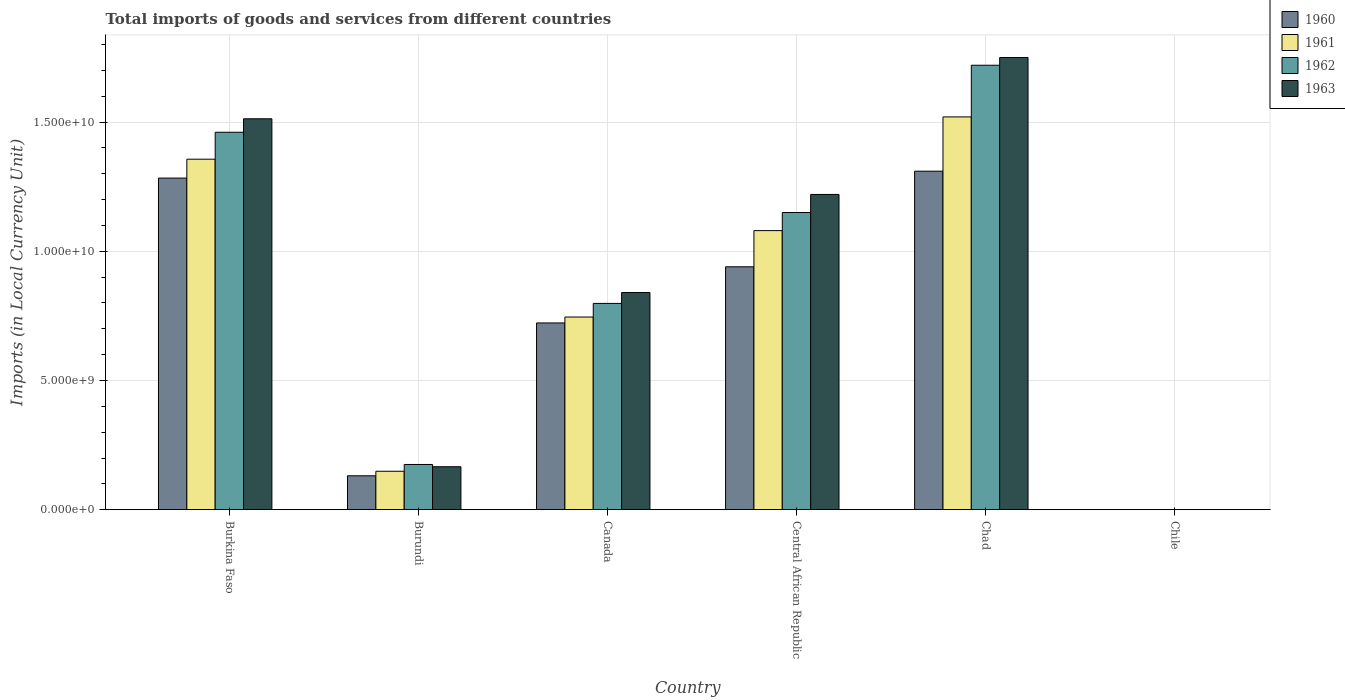How many different coloured bars are there?
Make the answer very short. 4. How many groups of bars are there?
Provide a succinct answer. 6. Are the number of bars per tick equal to the number of legend labels?
Your answer should be very brief. Yes. Are the number of bars on each tick of the X-axis equal?
Offer a terse response. Yes. How many bars are there on the 3rd tick from the left?
Your answer should be compact. 4. What is the label of the 1st group of bars from the left?
Your answer should be very brief. Burkina Faso. In how many cases, is the number of bars for a given country not equal to the number of legend labels?
Offer a terse response. 0. What is the Amount of goods and services imports in 1961 in Chad?
Your answer should be very brief. 1.52e+1. Across all countries, what is the maximum Amount of goods and services imports in 1961?
Give a very brief answer. 1.52e+1. Across all countries, what is the minimum Amount of goods and services imports in 1961?
Provide a succinct answer. 8.00e+05. In which country was the Amount of goods and services imports in 1963 maximum?
Your answer should be very brief. Chad. What is the total Amount of goods and services imports in 1961 in the graph?
Your answer should be compact. 4.85e+1. What is the difference between the Amount of goods and services imports in 1961 in Central African Republic and that in Chad?
Keep it short and to the point. -4.40e+09. What is the difference between the Amount of goods and services imports in 1963 in Chile and the Amount of goods and services imports in 1962 in Burundi?
Your answer should be very brief. -1.75e+09. What is the average Amount of goods and services imports in 1961 per country?
Provide a succinct answer. 8.08e+09. What is the difference between the Amount of goods and services imports of/in 1961 and Amount of goods and services imports of/in 1962 in Burundi?
Your response must be concise. -2.62e+08. What is the ratio of the Amount of goods and services imports in 1961 in Canada to that in Chile?
Give a very brief answer. 9319.38. What is the difference between the highest and the second highest Amount of goods and services imports in 1962?
Make the answer very short. 2.59e+09. What is the difference between the highest and the lowest Amount of goods and services imports in 1962?
Keep it short and to the point. 1.72e+1. In how many countries, is the Amount of goods and services imports in 1962 greater than the average Amount of goods and services imports in 1962 taken over all countries?
Your answer should be compact. 3. What does the 2nd bar from the left in Burkina Faso represents?
Provide a short and direct response. 1961. Is it the case that in every country, the sum of the Amount of goods and services imports in 1960 and Amount of goods and services imports in 1962 is greater than the Amount of goods and services imports in 1961?
Keep it short and to the point. Yes. How many bars are there?
Provide a succinct answer. 24. Are all the bars in the graph horizontal?
Make the answer very short. No. How many countries are there in the graph?
Offer a very short reply. 6. What is the difference between two consecutive major ticks on the Y-axis?
Your answer should be compact. 5.00e+09. Where does the legend appear in the graph?
Your response must be concise. Top right. How many legend labels are there?
Keep it short and to the point. 4. What is the title of the graph?
Make the answer very short. Total imports of goods and services from different countries. Does "1963" appear as one of the legend labels in the graph?
Your response must be concise. Yes. What is the label or title of the Y-axis?
Give a very brief answer. Imports (in Local Currency Unit). What is the Imports (in Local Currency Unit) in 1960 in Burkina Faso?
Keep it short and to the point. 1.28e+1. What is the Imports (in Local Currency Unit) in 1961 in Burkina Faso?
Provide a short and direct response. 1.36e+1. What is the Imports (in Local Currency Unit) in 1962 in Burkina Faso?
Give a very brief answer. 1.46e+1. What is the Imports (in Local Currency Unit) of 1963 in Burkina Faso?
Ensure brevity in your answer.  1.51e+1. What is the Imports (in Local Currency Unit) of 1960 in Burundi?
Offer a very short reply. 1.31e+09. What is the Imports (in Local Currency Unit) in 1961 in Burundi?
Provide a short and direct response. 1.49e+09. What is the Imports (in Local Currency Unit) in 1962 in Burundi?
Your response must be concise. 1.75e+09. What is the Imports (in Local Currency Unit) of 1963 in Burundi?
Your response must be concise. 1.66e+09. What is the Imports (in Local Currency Unit) of 1960 in Canada?
Provide a short and direct response. 7.23e+09. What is the Imports (in Local Currency Unit) in 1961 in Canada?
Make the answer very short. 7.46e+09. What is the Imports (in Local Currency Unit) in 1962 in Canada?
Make the answer very short. 7.98e+09. What is the Imports (in Local Currency Unit) of 1963 in Canada?
Your answer should be very brief. 8.40e+09. What is the Imports (in Local Currency Unit) of 1960 in Central African Republic?
Provide a short and direct response. 9.40e+09. What is the Imports (in Local Currency Unit) in 1961 in Central African Republic?
Your response must be concise. 1.08e+1. What is the Imports (in Local Currency Unit) of 1962 in Central African Republic?
Ensure brevity in your answer.  1.15e+1. What is the Imports (in Local Currency Unit) of 1963 in Central African Republic?
Give a very brief answer. 1.22e+1. What is the Imports (in Local Currency Unit) of 1960 in Chad?
Provide a succinct answer. 1.31e+1. What is the Imports (in Local Currency Unit) in 1961 in Chad?
Make the answer very short. 1.52e+1. What is the Imports (in Local Currency Unit) in 1962 in Chad?
Ensure brevity in your answer.  1.72e+1. What is the Imports (in Local Currency Unit) of 1963 in Chad?
Keep it short and to the point. 1.75e+1. What is the Imports (in Local Currency Unit) in 1960 in Chile?
Provide a succinct answer. 7.00e+05. What is the Imports (in Local Currency Unit) in 1961 in Chile?
Ensure brevity in your answer.  8.00e+05. What is the Imports (in Local Currency Unit) in 1963 in Chile?
Your response must be concise. 1.30e+06. Across all countries, what is the maximum Imports (in Local Currency Unit) of 1960?
Your answer should be very brief. 1.31e+1. Across all countries, what is the maximum Imports (in Local Currency Unit) in 1961?
Give a very brief answer. 1.52e+1. Across all countries, what is the maximum Imports (in Local Currency Unit) in 1962?
Offer a terse response. 1.72e+1. Across all countries, what is the maximum Imports (in Local Currency Unit) in 1963?
Offer a terse response. 1.75e+1. Across all countries, what is the minimum Imports (in Local Currency Unit) of 1963?
Provide a short and direct response. 1.30e+06. What is the total Imports (in Local Currency Unit) of 1960 in the graph?
Provide a short and direct response. 4.39e+1. What is the total Imports (in Local Currency Unit) of 1961 in the graph?
Make the answer very short. 4.85e+1. What is the total Imports (in Local Currency Unit) in 1962 in the graph?
Ensure brevity in your answer.  5.30e+1. What is the total Imports (in Local Currency Unit) in 1963 in the graph?
Make the answer very short. 5.49e+1. What is the difference between the Imports (in Local Currency Unit) in 1960 in Burkina Faso and that in Burundi?
Give a very brief answer. 1.15e+1. What is the difference between the Imports (in Local Currency Unit) of 1961 in Burkina Faso and that in Burundi?
Offer a terse response. 1.21e+1. What is the difference between the Imports (in Local Currency Unit) of 1962 in Burkina Faso and that in Burundi?
Ensure brevity in your answer.  1.29e+1. What is the difference between the Imports (in Local Currency Unit) of 1963 in Burkina Faso and that in Burundi?
Keep it short and to the point. 1.35e+1. What is the difference between the Imports (in Local Currency Unit) in 1960 in Burkina Faso and that in Canada?
Give a very brief answer. 5.61e+09. What is the difference between the Imports (in Local Currency Unit) of 1961 in Burkina Faso and that in Canada?
Offer a terse response. 6.11e+09. What is the difference between the Imports (in Local Currency Unit) of 1962 in Burkina Faso and that in Canada?
Provide a short and direct response. 6.62e+09. What is the difference between the Imports (in Local Currency Unit) of 1963 in Burkina Faso and that in Canada?
Make the answer very short. 6.72e+09. What is the difference between the Imports (in Local Currency Unit) in 1960 in Burkina Faso and that in Central African Republic?
Your answer should be compact. 3.43e+09. What is the difference between the Imports (in Local Currency Unit) of 1961 in Burkina Faso and that in Central African Republic?
Make the answer very short. 2.76e+09. What is the difference between the Imports (in Local Currency Unit) in 1962 in Burkina Faso and that in Central African Republic?
Ensure brevity in your answer.  3.11e+09. What is the difference between the Imports (in Local Currency Unit) of 1963 in Burkina Faso and that in Central African Republic?
Make the answer very short. 2.93e+09. What is the difference between the Imports (in Local Currency Unit) in 1960 in Burkina Faso and that in Chad?
Give a very brief answer. -2.66e+08. What is the difference between the Imports (in Local Currency Unit) of 1961 in Burkina Faso and that in Chad?
Give a very brief answer. -1.64e+09. What is the difference between the Imports (in Local Currency Unit) of 1962 in Burkina Faso and that in Chad?
Offer a terse response. -2.59e+09. What is the difference between the Imports (in Local Currency Unit) of 1963 in Burkina Faso and that in Chad?
Your response must be concise. -2.37e+09. What is the difference between the Imports (in Local Currency Unit) of 1960 in Burkina Faso and that in Chile?
Your response must be concise. 1.28e+1. What is the difference between the Imports (in Local Currency Unit) in 1961 in Burkina Faso and that in Chile?
Your answer should be very brief. 1.36e+1. What is the difference between the Imports (in Local Currency Unit) in 1962 in Burkina Faso and that in Chile?
Your response must be concise. 1.46e+1. What is the difference between the Imports (in Local Currency Unit) in 1963 in Burkina Faso and that in Chile?
Your answer should be compact. 1.51e+1. What is the difference between the Imports (in Local Currency Unit) in 1960 in Burundi and that in Canada?
Offer a very short reply. -5.91e+09. What is the difference between the Imports (in Local Currency Unit) in 1961 in Burundi and that in Canada?
Your answer should be compact. -5.97e+09. What is the difference between the Imports (in Local Currency Unit) of 1962 in Burundi and that in Canada?
Your answer should be compact. -6.23e+09. What is the difference between the Imports (in Local Currency Unit) of 1963 in Burundi and that in Canada?
Offer a terse response. -6.74e+09. What is the difference between the Imports (in Local Currency Unit) of 1960 in Burundi and that in Central African Republic?
Give a very brief answer. -8.09e+09. What is the difference between the Imports (in Local Currency Unit) of 1961 in Burundi and that in Central African Republic?
Offer a terse response. -9.31e+09. What is the difference between the Imports (in Local Currency Unit) in 1962 in Burundi and that in Central African Republic?
Provide a succinct answer. -9.75e+09. What is the difference between the Imports (in Local Currency Unit) in 1963 in Burundi and that in Central African Republic?
Provide a succinct answer. -1.05e+1. What is the difference between the Imports (in Local Currency Unit) of 1960 in Burundi and that in Chad?
Provide a short and direct response. -1.18e+1. What is the difference between the Imports (in Local Currency Unit) in 1961 in Burundi and that in Chad?
Offer a very short reply. -1.37e+1. What is the difference between the Imports (in Local Currency Unit) in 1962 in Burundi and that in Chad?
Your response must be concise. -1.55e+1. What is the difference between the Imports (in Local Currency Unit) in 1963 in Burundi and that in Chad?
Provide a short and direct response. -1.58e+1. What is the difference between the Imports (in Local Currency Unit) in 1960 in Burundi and that in Chile?
Keep it short and to the point. 1.31e+09. What is the difference between the Imports (in Local Currency Unit) in 1961 in Burundi and that in Chile?
Offer a terse response. 1.49e+09. What is the difference between the Imports (in Local Currency Unit) of 1962 in Burundi and that in Chile?
Your answer should be very brief. 1.75e+09. What is the difference between the Imports (in Local Currency Unit) in 1963 in Burundi and that in Chile?
Offer a very short reply. 1.66e+09. What is the difference between the Imports (in Local Currency Unit) in 1960 in Canada and that in Central African Republic?
Keep it short and to the point. -2.17e+09. What is the difference between the Imports (in Local Currency Unit) of 1961 in Canada and that in Central African Republic?
Your answer should be very brief. -3.34e+09. What is the difference between the Imports (in Local Currency Unit) of 1962 in Canada and that in Central African Republic?
Keep it short and to the point. -3.52e+09. What is the difference between the Imports (in Local Currency Unit) of 1963 in Canada and that in Central African Republic?
Make the answer very short. -3.80e+09. What is the difference between the Imports (in Local Currency Unit) in 1960 in Canada and that in Chad?
Offer a terse response. -5.87e+09. What is the difference between the Imports (in Local Currency Unit) in 1961 in Canada and that in Chad?
Provide a succinct answer. -7.74e+09. What is the difference between the Imports (in Local Currency Unit) in 1962 in Canada and that in Chad?
Keep it short and to the point. -9.22e+09. What is the difference between the Imports (in Local Currency Unit) of 1963 in Canada and that in Chad?
Your answer should be compact. -9.10e+09. What is the difference between the Imports (in Local Currency Unit) of 1960 in Canada and that in Chile?
Keep it short and to the point. 7.23e+09. What is the difference between the Imports (in Local Currency Unit) in 1961 in Canada and that in Chile?
Provide a succinct answer. 7.45e+09. What is the difference between the Imports (in Local Currency Unit) of 1962 in Canada and that in Chile?
Keep it short and to the point. 7.98e+09. What is the difference between the Imports (in Local Currency Unit) of 1963 in Canada and that in Chile?
Your answer should be very brief. 8.40e+09. What is the difference between the Imports (in Local Currency Unit) of 1960 in Central African Republic and that in Chad?
Offer a terse response. -3.70e+09. What is the difference between the Imports (in Local Currency Unit) in 1961 in Central African Republic and that in Chad?
Your answer should be very brief. -4.40e+09. What is the difference between the Imports (in Local Currency Unit) in 1962 in Central African Republic and that in Chad?
Your answer should be compact. -5.70e+09. What is the difference between the Imports (in Local Currency Unit) of 1963 in Central African Republic and that in Chad?
Give a very brief answer. -5.30e+09. What is the difference between the Imports (in Local Currency Unit) of 1960 in Central African Republic and that in Chile?
Keep it short and to the point. 9.40e+09. What is the difference between the Imports (in Local Currency Unit) in 1961 in Central African Republic and that in Chile?
Give a very brief answer. 1.08e+1. What is the difference between the Imports (in Local Currency Unit) in 1962 in Central African Republic and that in Chile?
Provide a succinct answer. 1.15e+1. What is the difference between the Imports (in Local Currency Unit) of 1963 in Central African Republic and that in Chile?
Make the answer very short. 1.22e+1. What is the difference between the Imports (in Local Currency Unit) of 1960 in Chad and that in Chile?
Provide a succinct answer. 1.31e+1. What is the difference between the Imports (in Local Currency Unit) in 1961 in Chad and that in Chile?
Give a very brief answer. 1.52e+1. What is the difference between the Imports (in Local Currency Unit) in 1962 in Chad and that in Chile?
Keep it short and to the point. 1.72e+1. What is the difference between the Imports (in Local Currency Unit) in 1963 in Chad and that in Chile?
Give a very brief answer. 1.75e+1. What is the difference between the Imports (in Local Currency Unit) of 1960 in Burkina Faso and the Imports (in Local Currency Unit) of 1961 in Burundi?
Give a very brief answer. 1.13e+1. What is the difference between the Imports (in Local Currency Unit) of 1960 in Burkina Faso and the Imports (in Local Currency Unit) of 1962 in Burundi?
Give a very brief answer. 1.11e+1. What is the difference between the Imports (in Local Currency Unit) in 1960 in Burkina Faso and the Imports (in Local Currency Unit) in 1963 in Burundi?
Your response must be concise. 1.12e+1. What is the difference between the Imports (in Local Currency Unit) in 1961 in Burkina Faso and the Imports (in Local Currency Unit) in 1962 in Burundi?
Ensure brevity in your answer.  1.18e+1. What is the difference between the Imports (in Local Currency Unit) of 1961 in Burkina Faso and the Imports (in Local Currency Unit) of 1963 in Burundi?
Provide a short and direct response. 1.19e+1. What is the difference between the Imports (in Local Currency Unit) of 1962 in Burkina Faso and the Imports (in Local Currency Unit) of 1963 in Burundi?
Offer a terse response. 1.29e+1. What is the difference between the Imports (in Local Currency Unit) in 1960 in Burkina Faso and the Imports (in Local Currency Unit) in 1961 in Canada?
Provide a succinct answer. 5.38e+09. What is the difference between the Imports (in Local Currency Unit) in 1960 in Burkina Faso and the Imports (in Local Currency Unit) in 1962 in Canada?
Provide a succinct answer. 4.85e+09. What is the difference between the Imports (in Local Currency Unit) in 1960 in Burkina Faso and the Imports (in Local Currency Unit) in 1963 in Canada?
Your answer should be compact. 4.43e+09. What is the difference between the Imports (in Local Currency Unit) in 1961 in Burkina Faso and the Imports (in Local Currency Unit) in 1962 in Canada?
Provide a succinct answer. 5.58e+09. What is the difference between the Imports (in Local Currency Unit) in 1961 in Burkina Faso and the Imports (in Local Currency Unit) in 1963 in Canada?
Give a very brief answer. 5.16e+09. What is the difference between the Imports (in Local Currency Unit) of 1962 in Burkina Faso and the Imports (in Local Currency Unit) of 1963 in Canada?
Your answer should be compact. 6.20e+09. What is the difference between the Imports (in Local Currency Unit) of 1960 in Burkina Faso and the Imports (in Local Currency Unit) of 1961 in Central African Republic?
Make the answer very short. 2.03e+09. What is the difference between the Imports (in Local Currency Unit) in 1960 in Burkina Faso and the Imports (in Local Currency Unit) in 1962 in Central African Republic?
Make the answer very short. 1.33e+09. What is the difference between the Imports (in Local Currency Unit) in 1960 in Burkina Faso and the Imports (in Local Currency Unit) in 1963 in Central African Republic?
Your answer should be very brief. 6.34e+08. What is the difference between the Imports (in Local Currency Unit) in 1961 in Burkina Faso and the Imports (in Local Currency Unit) in 1962 in Central African Republic?
Offer a very short reply. 2.06e+09. What is the difference between the Imports (in Local Currency Unit) in 1961 in Burkina Faso and the Imports (in Local Currency Unit) in 1963 in Central African Republic?
Your response must be concise. 1.36e+09. What is the difference between the Imports (in Local Currency Unit) of 1962 in Burkina Faso and the Imports (in Local Currency Unit) of 1963 in Central African Republic?
Your response must be concise. 2.41e+09. What is the difference between the Imports (in Local Currency Unit) of 1960 in Burkina Faso and the Imports (in Local Currency Unit) of 1961 in Chad?
Provide a short and direct response. -2.37e+09. What is the difference between the Imports (in Local Currency Unit) in 1960 in Burkina Faso and the Imports (in Local Currency Unit) in 1962 in Chad?
Offer a very short reply. -4.37e+09. What is the difference between the Imports (in Local Currency Unit) in 1960 in Burkina Faso and the Imports (in Local Currency Unit) in 1963 in Chad?
Make the answer very short. -4.67e+09. What is the difference between the Imports (in Local Currency Unit) of 1961 in Burkina Faso and the Imports (in Local Currency Unit) of 1962 in Chad?
Give a very brief answer. -3.64e+09. What is the difference between the Imports (in Local Currency Unit) of 1961 in Burkina Faso and the Imports (in Local Currency Unit) of 1963 in Chad?
Your response must be concise. -3.94e+09. What is the difference between the Imports (in Local Currency Unit) in 1962 in Burkina Faso and the Imports (in Local Currency Unit) in 1963 in Chad?
Your answer should be very brief. -2.89e+09. What is the difference between the Imports (in Local Currency Unit) of 1960 in Burkina Faso and the Imports (in Local Currency Unit) of 1961 in Chile?
Keep it short and to the point. 1.28e+1. What is the difference between the Imports (in Local Currency Unit) of 1960 in Burkina Faso and the Imports (in Local Currency Unit) of 1962 in Chile?
Make the answer very short. 1.28e+1. What is the difference between the Imports (in Local Currency Unit) in 1960 in Burkina Faso and the Imports (in Local Currency Unit) in 1963 in Chile?
Provide a succinct answer. 1.28e+1. What is the difference between the Imports (in Local Currency Unit) of 1961 in Burkina Faso and the Imports (in Local Currency Unit) of 1962 in Chile?
Your answer should be very brief. 1.36e+1. What is the difference between the Imports (in Local Currency Unit) in 1961 in Burkina Faso and the Imports (in Local Currency Unit) in 1963 in Chile?
Provide a succinct answer. 1.36e+1. What is the difference between the Imports (in Local Currency Unit) in 1962 in Burkina Faso and the Imports (in Local Currency Unit) in 1963 in Chile?
Provide a short and direct response. 1.46e+1. What is the difference between the Imports (in Local Currency Unit) of 1960 in Burundi and the Imports (in Local Currency Unit) of 1961 in Canada?
Ensure brevity in your answer.  -6.14e+09. What is the difference between the Imports (in Local Currency Unit) of 1960 in Burundi and the Imports (in Local Currency Unit) of 1962 in Canada?
Ensure brevity in your answer.  -6.67e+09. What is the difference between the Imports (in Local Currency Unit) in 1960 in Burundi and the Imports (in Local Currency Unit) in 1963 in Canada?
Offer a terse response. -7.09e+09. What is the difference between the Imports (in Local Currency Unit) of 1961 in Burundi and the Imports (in Local Currency Unit) of 1962 in Canada?
Your response must be concise. -6.50e+09. What is the difference between the Imports (in Local Currency Unit) of 1961 in Burundi and the Imports (in Local Currency Unit) of 1963 in Canada?
Offer a very short reply. -6.92e+09. What is the difference between the Imports (in Local Currency Unit) of 1962 in Burundi and the Imports (in Local Currency Unit) of 1963 in Canada?
Give a very brief answer. -6.65e+09. What is the difference between the Imports (in Local Currency Unit) in 1960 in Burundi and the Imports (in Local Currency Unit) in 1961 in Central African Republic?
Your answer should be compact. -9.49e+09. What is the difference between the Imports (in Local Currency Unit) of 1960 in Burundi and the Imports (in Local Currency Unit) of 1962 in Central African Republic?
Your answer should be very brief. -1.02e+1. What is the difference between the Imports (in Local Currency Unit) of 1960 in Burundi and the Imports (in Local Currency Unit) of 1963 in Central African Republic?
Ensure brevity in your answer.  -1.09e+1. What is the difference between the Imports (in Local Currency Unit) in 1961 in Burundi and the Imports (in Local Currency Unit) in 1962 in Central African Republic?
Ensure brevity in your answer.  -1.00e+1. What is the difference between the Imports (in Local Currency Unit) of 1961 in Burundi and the Imports (in Local Currency Unit) of 1963 in Central African Republic?
Give a very brief answer. -1.07e+1. What is the difference between the Imports (in Local Currency Unit) of 1962 in Burundi and the Imports (in Local Currency Unit) of 1963 in Central African Republic?
Your answer should be very brief. -1.05e+1. What is the difference between the Imports (in Local Currency Unit) in 1960 in Burundi and the Imports (in Local Currency Unit) in 1961 in Chad?
Offer a very short reply. -1.39e+1. What is the difference between the Imports (in Local Currency Unit) of 1960 in Burundi and the Imports (in Local Currency Unit) of 1962 in Chad?
Your response must be concise. -1.59e+1. What is the difference between the Imports (in Local Currency Unit) in 1960 in Burundi and the Imports (in Local Currency Unit) in 1963 in Chad?
Provide a succinct answer. -1.62e+1. What is the difference between the Imports (in Local Currency Unit) of 1961 in Burundi and the Imports (in Local Currency Unit) of 1962 in Chad?
Your answer should be very brief. -1.57e+1. What is the difference between the Imports (in Local Currency Unit) of 1961 in Burundi and the Imports (in Local Currency Unit) of 1963 in Chad?
Make the answer very short. -1.60e+1. What is the difference between the Imports (in Local Currency Unit) of 1962 in Burundi and the Imports (in Local Currency Unit) of 1963 in Chad?
Your answer should be very brief. -1.58e+1. What is the difference between the Imports (in Local Currency Unit) in 1960 in Burundi and the Imports (in Local Currency Unit) in 1961 in Chile?
Provide a succinct answer. 1.31e+09. What is the difference between the Imports (in Local Currency Unit) in 1960 in Burundi and the Imports (in Local Currency Unit) in 1962 in Chile?
Keep it short and to the point. 1.31e+09. What is the difference between the Imports (in Local Currency Unit) in 1960 in Burundi and the Imports (in Local Currency Unit) in 1963 in Chile?
Offer a terse response. 1.31e+09. What is the difference between the Imports (in Local Currency Unit) of 1961 in Burundi and the Imports (in Local Currency Unit) of 1962 in Chile?
Provide a succinct answer. 1.49e+09. What is the difference between the Imports (in Local Currency Unit) of 1961 in Burundi and the Imports (in Local Currency Unit) of 1963 in Chile?
Provide a succinct answer. 1.49e+09. What is the difference between the Imports (in Local Currency Unit) of 1962 in Burundi and the Imports (in Local Currency Unit) of 1963 in Chile?
Keep it short and to the point. 1.75e+09. What is the difference between the Imports (in Local Currency Unit) in 1960 in Canada and the Imports (in Local Currency Unit) in 1961 in Central African Republic?
Your response must be concise. -3.57e+09. What is the difference between the Imports (in Local Currency Unit) of 1960 in Canada and the Imports (in Local Currency Unit) of 1962 in Central African Republic?
Offer a very short reply. -4.27e+09. What is the difference between the Imports (in Local Currency Unit) in 1960 in Canada and the Imports (in Local Currency Unit) in 1963 in Central African Republic?
Your answer should be very brief. -4.97e+09. What is the difference between the Imports (in Local Currency Unit) of 1961 in Canada and the Imports (in Local Currency Unit) of 1962 in Central African Republic?
Offer a terse response. -4.04e+09. What is the difference between the Imports (in Local Currency Unit) of 1961 in Canada and the Imports (in Local Currency Unit) of 1963 in Central African Republic?
Make the answer very short. -4.74e+09. What is the difference between the Imports (in Local Currency Unit) of 1962 in Canada and the Imports (in Local Currency Unit) of 1963 in Central African Republic?
Give a very brief answer. -4.22e+09. What is the difference between the Imports (in Local Currency Unit) of 1960 in Canada and the Imports (in Local Currency Unit) of 1961 in Chad?
Keep it short and to the point. -7.97e+09. What is the difference between the Imports (in Local Currency Unit) in 1960 in Canada and the Imports (in Local Currency Unit) in 1962 in Chad?
Ensure brevity in your answer.  -9.97e+09. What is the difference between the Imports (in Local Currency Unit) of 1960 in Canada and the Imports (in Local Currency Unit) of 1963 in Chad?
Ensure brevity in your answer.  -1.03e+1. What is the difference between the Imports (in Local Currency Unit) in 1961 in Canada and the Imports (in Local Currency Unit) in 1962 in Chad?
Provide a short and direct response. -9.74e+09. What is the difference between the Imports (in Local Currency Unit) in 1961 in Canada and the Imports (in Local Currency Unit) in 1963 in Chad?
Provide a short and direct response. -1.00e+1. What is the difference between the Imports (in Local Currency Unit) of 1962 in Canada and the Imports (in Local Currency Unit) of 1963 in Chad?
Provide a succinct answer. -9.52e+09. What is the difference between the Imports (in Local Currency Unit) of 1960 in Canada and the Imports (in Local Currency Unit) of 1961 in Chile?
Make the answer very short. 7.23e+09. What is the difference between the Imports (in Local Currency Unit) in 1960 in Canada and the Imports (in Local Currency Unit) in 1962 in Chile?
Your answer should be compact. 7.23e+09. What is the difference between the Imports (in Local Currency Unit) in 1960 in Canada and the Imports (in Local Currency Unit) in 1963 in Chile?
Keep it short and to the point. 7.23e+09. What is the difference between the Imports (in Local Currency Unit) in 1961 in Canada and the Imports (in Local Currency Unit) in 1962 in Chile?
Give a very brief answer. 7.45e+09. What is the difference between the Imports (in Local Currency Unit) of 1961 in Canada and the Imports (in Local Currency Unit) of 1963 in Chile?
Provide a short and direct response. 7.45e+09. What is the difference between the Imports (in Local Currency Unit) of 1962 in Canada and the Imports (in Local Currency Unit) of 1963 in Chile?
Keep it short and to the point. 7.98e+09. What is the difference between the Imports (in Local Currency Unit) in 1960 in Central African Republic and the Imports (in Local Currency Unit) in 1961 in Chad?
Offer a very short reply. -5.80e+09. What is the difference between the Imports (in Local Currency Unit) in 1960 in Central African Republic and the Imports (in Local Currency Unit) in 1962 in Chad?
Your response must be concise. -7.80e+09. What is the difference between the Imports (in Local Currency Unit) in 1960 in Central African Republic and the Imports (in Local Currency Unit) in 1963 in Chad?
Keep it short and to the point. -8.10e+09. What is the difference between the Imports (in Local Currency Unit) in 1961 in Central African Republic and the Imports (in Local Currency Unit) in 1962 in Chad?
Your answer should be compact. -6.40e+09. What is the difference between the Imports (in Local Currency Unit) of 1961 in Central African Republic and the Imports (in Local Currency Unit) of 1963 in Chad?
Give a very brief answer. -6.70e+09. What is the difference between the Imports (in Local Currency Unit) of 1962 in Central African Republic and the Imports (in Local Currency Unit) of 1963 in Chad?
Offer a very short reply. -6.00e+09. What is the difference between the Imports (in Local Currency Unit) in 1960 in Central African Republic and the Imports (in Local Currency Unit) in 1961 in Chile?
Ensure brevity in your answer.  9.40e+09. What is the difference between the Imports (in Local Currency Unit) of 1960 in Central African Republic and the Imports (in Local Currency Unit) of 1962 in Chile?
Make the answer very short. 9.40e+09. What is the difference between the Imports (in Local Currency Unit) of 1960 in Central African Republic and the Imports (in Local Currency Unit) of 1963 in Chile?
Give a very brief answer. 9.40e+09. What is the difference between the Imports (in Local Currency Unit) in 1961 in Central African Republic and the Imports (in Local Currency Unit) in 1962 in Chile?
Provide a succinct answer. 1.08e+1. What is the difference between the Imports (in Local Currency Unit) in 1961 in Central African Republic and the Imports (in Local Currency Unit) in 1963 in Chile?
Give a very brief answer. 1.08e+1. What is the difference between the Imports (in Local Currency Unit) in 1962 in Central African Republic and the Imports (in Local Currency Unit) in 1963 in Chile?
Provide a succinct answer. 1.15e+1. What is the difference between the Imports (in Local Currency Unit) in 1960 in Chad and the Imports (in Local Currency Unit) in 1961 in Chile?
Your response must be concise. 1.31e+1. What is the difference between the Imports (in Local Currency Unit) of 1960 in Chad and the Imports (in Local Currency Unit) of 1962 in Chile?
Your response must be concise. 1.31e+1. What is the difference between the Imports (in Local Currency Unit) in 1960 in Chad and the Imports (in Local Currency Unit) in 1963 in Chile?
Make the answer very short. 1.31e+1. What is the difference between the Imports (in Local Currency Unit) in 1961 in Chad and the Imports (in Local Currency Unit) in 1962 in Chile?
Keep it short and to the point. 1.52e+1. What is the difference between the Imports (in Local Currency Unit) in 1961 in Chad and the Imports (in Local Currency Unit) in 1963 in Chile?
Provide a short and direct response. 1.52e+1. What is the difference between the Imports (in Local Currency Unit) of 1962 in Chad and the Imports (in Local Currency Unit) of 1963 in Chile?
Your answer should be very brief. 1.72e+1. What is the average Imports (in Local Currency Unit) of 1960 per country?
Provide a short and direct response. 7.31e+09. What is the average Imports (in Local Currency Unit) in 1961 per country?
Give a very brief answer. 8.08e+09. What is the average Imports (in Local Currency Unit) in 1962 per country?
Keep it short and to the point. 8.84e+09. What is the average Imports (in Local Currency Unit) of 1963 per country?
Your answer should be compact. 9.15e+09. What is the difference between the Imports (in Local Currency Unit) in 1960 and Imports (in Local Currency Unit) in 1961 in Burkina Faso?
Your answer should be compact. -7.30e+08. What is the difference between the Imports (in Local Currency Unit) of 1960 and Imports (in Local Currency Unit) of 1962 in Burkina Faso?
Provide a short and direct response. -1.77e+09. What is the difference between the Imports (in Local Currency Unit) of 1960 and Imports (in Local Currency Unit) of 1963 in Burkina Faso?
Keep it short and to the point. -2.29e+09. What is the difference between the Imports (in Local Currency Unit) of 1961 and Imports (in Local Currency Unit) of 1962 in Burkina Faso?
Offer a terse response. -1.04e+09. What is the difference between the Imports (in Local Currency Unit) of 1961 and Imports (in Local Currency Unit) of 1963 in Burkina Faso?
Your answer should be very brief. -1.56e+09. What is the difference between the Imports (in Local Currency Unit) in 1962 and Imports (in Local Currency Unit) in 1963 in Burkina Faso?
Your answer should be compact. -5.21e+08. What is the difference between the Imports (in Local Currency Unit) in 1960 and Imports (in Local Currency Unit) in 1961 in Burundi?
Make the answer very short. -1.75e+08. What is the difference between the Imports (in Local Currency Unit) in 1960 and Imports (in Local Currency Unit) in 1962 in Burundi?
Ensure brevity in your answer.  -4.38e+08. What is the difference between the Imports (in Local Currency Unit) in 1960 and Imports (in Local Currency Unit) in 1963 in Burundi?
Provide a short and direct response. -3.50e+08. What is the difference between the Imports (in Local Currency Unit) of 1961 and Imports (in Local Currency Unit) of 1962 in Burundi?
Provide a succinct answer. -2.62e+08. What is the difference between the Imports (in Local Currency Unit) of 1961 and Imports (in Local Currency Unit) of 1963 in Burundi?
Give a very brief answer. -1.75e+08. What is the difference between the Imports (in Local Currency Unit) in 1962 and Imports (in Local Currency Unit) in 1963 in Burundi?
Ensure brevity in your answer.  8.75e+07. What is the difference between the Imports (in Local Currency Unit) of 1960 and Imports (in Local Currency Unit) of 1961 in Canada?
Offer a very short reply. -2.28e+08. What is the difference between the Imports (in Local Currency Unit) of 1960 and Imports (in Local Currency Unit) of 1962 in Canada?
Keep it short and to the point. -7.56e+08. What is the difference between the Imports (in Local Currency Unit) in 1960 and Imports (in Local Currency Unit) in 1963 in Canada?
Give a very brief answer. -1.18e+09. What is the difference between the Imports (in Local Currency Unit) of 1961 and Imports (in Local Currency Unit) of 1962 in Canada?
Ensure brevity in your answer.  -5.27e+08. What is the difference between the Imports (in Local Currency Unit) of 1961 and Imports (in Local Currency Unit) of 1963 in Canada?
Your answer should be compact. -9.49e+08. What is the difference between the Imports (in Local Currency Unit) in 1962 and Imports (in Local Currency Unit) in 1963 in Canada?
Your answer should be very brief. -4.21e+08. What is the difference between the Imports (in Local Currency Unit) in 1960 and Imports (in Local Currency Unit) in 1961 in Central African Republic?
Your response must be concise. -1.40e+09. What is the difference between the Imports (in Local Currency Unit) of 1960 and Imports (in Local Currency Unit) of 1962 in Central African Republic?
Give a very brief answer. -2.10e+09. What is the difference between the Imports (in Local Currency Unit) in 1960 and Imports (in Local Currency Unit) in 1963 in Central African Republic?
Your answer should be compact. -2.80e+09. What is the difference between the Imports (in Local Currency Unit) in 1961 and Imports (in Local Currency Unit) in 1962 in Central African Republic?
Your response must be concise. -7.00e+08. What is the difference between the Imports (in Local Currency Unit) in 1961 and Imports (in Local Currency Unit) in 1963 in Central African Republic?
Keep it short and to the point. -1.40e+09. What is the difference between the Imports (in Local Currency Unit) in 1962 and Imports (in Local Currency Unit) in 1963 in Central African Republic?
Your answer should be compact. -7.00e+08. What is the difference between the Imports (in Local Currency Unit) in 1960 and Imports (in Local Currency Unit) in 1961 in Chad?
Provide a succinct answer. -2.10e+09. What is the difference between the Imports (in Local Currency Unit) of 1960 and Imports (in Local Currency Unit) of 1962 in Chad?
Provide a succinct answer. -4.10e+09. What is the difference between the Imports (in Local Currency Unit) in 1960 and Imports (in Local Currency Unit) in 1963 in Chad?
Provide a short and direct response. -4.40e+09. What is the difference between the Imports (in Local Currency Unit) in 1961 and Imports (in Local Currency Unit) in 1962 in Chad?
Your answer should be very brief. -2.00e+09. What is the difference between the Imports (in Local Currency Unit) in 1961 and Imports (in Local Currency Unit) in 1963 in Chad?
Keep it short and to the point. -2.30e+09. What is the difference between the Imports (in Local Currency Unit) in 1962 and Imports (in Local Currency Unit) in 1963 in Chad?
Offer a very short reply. -3.00e+08. What is the difference between the Imports (in Local Currency Unit) of 1960 and Imports (in Local Currency Unit) of 1963 in Chile?
Make the answer very short. -6.00e+05. What is the difference between the Imports (in Local Currency Unit) in 1961 and Imports (in Local Currency Unit) in 1963 in Chile?
Your answer should be compact. -5.00e+05. What is the difference between the Imports (in Local Currency Unit) in 1962 and Imports (in Local Currency Unit) in 1963 in Chile?
Offer a very short reply. -5.00e+05. What is the ratio of the Imports (in Local Currency Unit) of 1960 in Burkina Faso to that in Burundi?
Ensure brevity in your answer.  9.78. What is the ratio of the Imports (in Local Currency Unit) of 1961 in Burkina Faso to that in Burundi?
Keep it short and to the point. 9.12. What is the ratio of the Imports (in Local Currency Unit) of 1962 in Burkina Faso to that in Burundi?
Give a very brief answer. 8.35. What is the ratio of the Imports (in Local Currency Unit) of 1963 in Burkina Faso to that in Burundi?
Provide a short and direct response. 9.1. What is the ratio of the Imports (in Local Currency Unit) of 1960 in Burkina Faso to that in Canada?
Keep it short and to the point. 1.78. What is the ratio of the Imports (in Local Currency Unit) of 1961 in Burkina Faso to that in Canada?
Offer a terse response. 1.82. What is the ratio of the Imports (in Local Currency Unit) in 1962 in Burkina Faso to that in Canada?
Your answer should be very brief. 1.83. What is the ratio of the Imports (in Local Currency Unit) in 1960 in Burkina Faso to that in Central African Republic?
Ensure brevity in your answer.  1.37. What is the ratio of the Imports (in Local Currency Unit) of 1961 in Burkina Faso to that in Central African Republic?
Your answer should be very brief. 1.26. What is the ratio of the Imports (in Local Currency Unit) of 1962 in Burkina Faso to that in Central African Republic?
Ensure brevity in your answer.  1.27. What is the ratio of the Imports (in Local Currency Unit) of 1963 in Burkina Faso to that in Central African Republic?
Keep it short and to the point. 1.24. What is the ratio of the Imports (in Local Currency Unit) of 1960 in Burkina Faso to that in Chad?
Provide a succinct answer. 0.98. What is the ratio of the Imports (in Local Currency Unit) of 1961 in Burkina Faso to that in Chad?
Make the answer very short. 0.89. What is the ratio of the Imports (in Local Currency Unit) of 1962 in Burkina Faso to that in Chad?
Make the answer very short. 0.85. What is the ratio of the Imports (in Local Currency Unit) in 1963 in Burkina Faso to that in Chad?
Your answer should be compact. 0.86. What is the ratio of the Imports (in Local Currency Unit) in 1960 in Burkina Faso to that in Chile?
Your response must be concise. 1.83e+04. What is the ratio of the Imports (in Local Currency Unit) in 1961 in Burkina Faso to that in Chile?
Provide a short and direct response. 1.70e+04. What is the ratio of the Imports (in Local Currency Unit) of 1962 in Burkina Faso to that in Chile?
Provide a short and direct response. 1.83e+04. What is the ratio of the Imports (in Local Currency Unit) of 1963 in Burkina Faso to that in Chile?
Ensure brevity in your answer.  1.16e+04. What is the ratio of the Imports (in Local Currency Unit) in 1960 in Burundi to that in Canada?
Your answer should be compact. 0.18. What is the ratio of the Imports (in Local Currency Unit) of 1961 in Burundi to that in Canada?
Your response must be concise. 0.2. What is the ratio of the Imports (in Local Currency Unit) in 1962 in Burundi to that in Canada?
Provide a short and direct response. 0.22. What is the ratio of the Imports (in Local Currency Unit) in 1963 in Burundi to that in Canada?
Your answer should be compact. 0.2. What is the ratio of the Imports (in Local Currency Unit) in 1960 in Burundi to that in Central African Republic?
Provide a short and direct response. 0.14. What is the ratio of the Imports (in Local Currency Unit) of 1961 in Burundi to that in Central African Republic?
Make the answer very short. 0.14. What is the ratio of the Imports (in Local Currency Unit) of 1962 in Burundi to that in Central African Republic?
Make the answer very short. 0.15. What is the ratio of the Imports (in Local Currency Unit) in 1963 in Burundi to that in Central African Republic?
Keep it short and to the point. 0.14. What is the ratio of the Imports (in Local Currency Unit) of 1960 in Burundi to that in Chad?
Your response must be concise. 0.1. What is the ratio of the Imports (in Local Currency Unit) of 1961 in Burundi to that in Chad?
Offer a terse response. 0.1. What is the ratio of the Imports (in Local Currency Unit) in 1962 in Burundi to that in Chad?
Provide a succinct answer. 0.1. What is the ratio of the Imports (in Local Currency Unit) in 1963 in Burundi to that in Chad?
Provide a short and direct response. 0.1. What is the ratio of the Imports (in Local Currency Unit) of 1960 in Burundi to that in Chile?
Your response must be concise. 1875. What is the ratio of the Imports (in Local Currency Unit) in 1961 in Burundi to that in Chile?
Offer a very short reply. 1859.38. What is the ratio of the Imports (in Local Currency Unit) in 1962 in Burundi to that in Chile?
Provide a short and direct response. 2187.5. What is the ratio of the Imports (in Local Currency Unit) in 1963 in Burundi to that in Chile?
Keep it short and to the point. 1278.85. What is the ratio of the Imports (in Local Currency Unit) of 1960 in Canada to that in Central African Republic?
Ensure brevity in your answer.  0.77. What is the ratio of the Imports (in Local Currency Unit) of 1961 in Canada to that in Central African Republic?
Provide a succinct answer. 0.69. What is the ratio of the Imports (in Local Currency Unit) in 1962 in Canada to that in Central African Republic?
Ensure brevity in your answer.  0.69. What is the ratio of the Imports (in Local Currency Unit) in 1963 in Canada to that in Central African Republic?
Keep it short and to the point. 0.69. What is the ratio of the Imports (in Local Currency Unit) in 1960 in Canada to that in Chad?
Ensure brevity in your answer.  0.55. What is the ratio of the Imports (in Local Currency Unit) of 1961 in Canada to that in Chad?
Your response must be concise. 0.49. What is the ratio of the Imports (in Local Currency Unit) of 1962 in Canada to that in Chad?
Keep it short and to the point. 0.46. What is the ratio of the Imports (in Local Currency Unit) of 1963 in Canada to that in Chad?
Keep it short and to the point. 0.48. What is the ratio of the Imports (in Local Currency Unit) of 1960 in Canada to that in Chile?
Provide a short and direct response. 1.03e+04. What is the ratio of the Imports (in Local Currency Unit) in 1961 in Canada to that in Chile?
Offer a very short reply. 9319.38. What is the ratio of the Imports (in Local Currency Unit) of 1962 in Canada to that in Chile?
Your answer should be compact. 9978.62. What is the ratio of the Imports (in Local Currency Unit) of 1963 in Canada to that in Chile?
Provide a succinct answer. 6464.77. What is the ratio of the Imports (in Local Currency Unit) in 1960 in Central African Republic to that in Chad?
Provide a short and direct response. 0.72. What is the ratio of the Imports (in Local Currency Unit) of 1961 in Central African Republic to that in Chad?
Provide a short and direct response. 0.71. What is the ratio of the Imports (in Local Currency Unit) of 1962 in Central African Republic to that in Chad?
Offer a terse response. 0.67. What is the ratio of the Imports (in Local Currency Unit) of 1963 in Central African Republic to that in Chad?
Provide a succinct answer. 0.7. What is the ratio of the Imports (in Local Currency Unit) of 1960 in Central African Republic to that in Chile?
Offer a very short reply. 1.34e+04. What is the ratio of the Imports (in Local Currency Unit) of 1961 in Central African Republic to that in Chile?
Keep it short and to the point. 1.35e+04. What is the ratio of the Imports (in Local Currency Unit) of 1962 in Central African Republic to that in Chile?
Provide a succinct answer. 1.44e+04. What is the ratio of the Imports (in Local Currency Unit) of 1963 in Central African Republic to that in Chile?
Your answer should be very brief. 9384.62. What is the ratio of the Imports (in Local Currency Unit) in 1960 in Chad to that in Chile?
Provide a short and direct response. 1.87e+04. What is the ratio of the Imports (in Local Currency Unit) in 1961 in Chad to that in Chile?
Provide a succinct answer. 1.90e+04. What is the ratio of the Imports (in Local Currency Unit) in 1962 in Chad to that in Chile?
Give a very brief answer. 2.15e+04. What is the ratio of the Imports (in Local Currency Unit) in 1963 in Chad to that in Chile?
Offer a very short reply. 1.35e+04. What is the difference between the highest and the second highest Imports (in Local Currency Unit) in 1960?
Provide a short and direct response. 2.66e+08. What is the difference between the highest and the second highest Imports (in Local Currency Unit) in 1961?
Give a very brief answer. 1.64e+09. What is the difference between the highest and the second highest Imports (in Local Currency Unit) of 1962?
Provide a succinct answer. 2.59e+09. What is the difference between the highest and the second highest Imports (in Local Currency Unit) in 1963?
Your answer should be very brief. 2.37e+09. What is the difference between the highest and the lowest Imports (in Local Currency Unit) of 1960?
Give a very brief answer. 1.31e+1. What is the difference between the highest and the lowest Imports (in Local Currency Unit) of 1961?
Your response must be concise. 1.52e+1. What is the difference between the highest and the lowest Imports (in Local Currency Unit) of 1962?
Offer a terse response. 1.72e+1. What is the difference between the highest and the lowest Imports (in Local Currency Unit) in 1963?
Your response must be concise. 1.75e+1. 